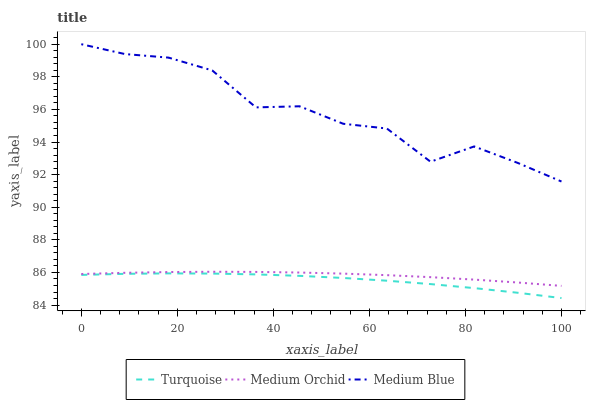Does Turquoise have the minimum area under the curve?
Answer yes or no. Yes. Does Medium Blue have the maximum area under the curve?
Answer yes or no. Yes. Does Medium Orchid have the minimum area under the curve?
Answer yes or no. No. Does Medium Orchid have the maximum area under the curve?
Answer yes or no. No. Is Medium Orchid the smoothest?
Answer yes or no. Yes. Is Medium Blue the roughest?
Answer yes or no. Yes. Is Medium Blue the smoothest?
Answer yes or no. No. Is Medium Orchid the roughest?
Answer yes or no. No. Does Turquoise have the lowest value?
Answer yes or no. Yes. Does Medium Orchid have the lowest value?
Answer yes or no. No. Does Medium Blue have the highest value?
Answer yes or no. Yes. Does Medium Orchid have the highest value?
Answer yes or no. No. Is Turquoise less than Medium Blue?
Answer yes or no. Yes. Is Medium Blue greater than Turquoise?
Answer yes or no. Yes. Does Turquoise intersect Medium Blue?
Answer yes or no. No. 